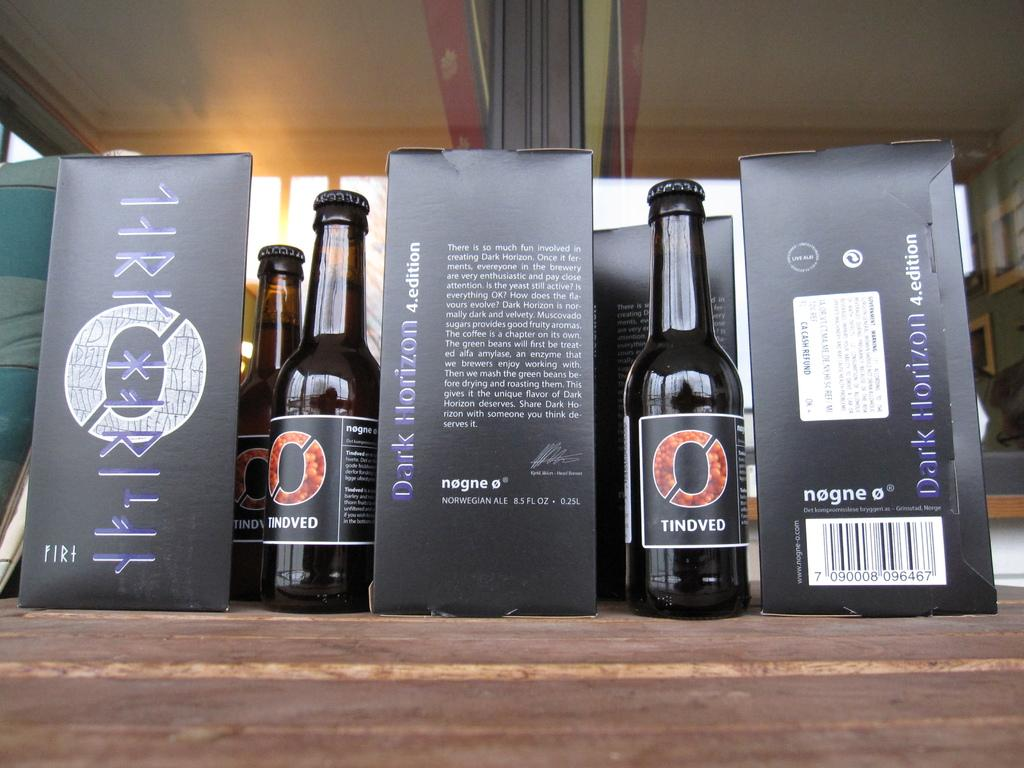Provide a one-sentence caption for the provided image. An presentation stand showcasing bottles of Dark Horizon Norwegian Ale. 